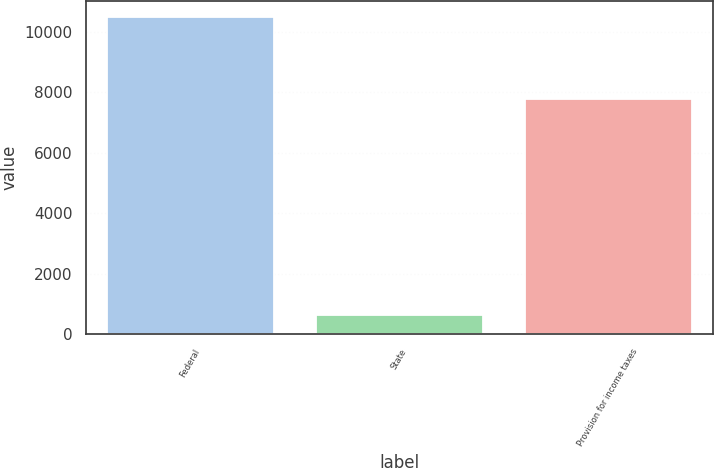<chart> <loc_0><loc_0><loc_500><loc_500><bar_chart><fcel>Federal<fcel>State<fcel>Provision for income taxes<nl><fcel>10485<fcel>630<fcel>7774<nl></chart> 